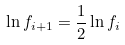<formula> <loc_0><loc_0><loc_500><loc_500>\ln f _ { i + 1 } = \frac { 1 } { 2 } \ln f _ { i }</formula> 